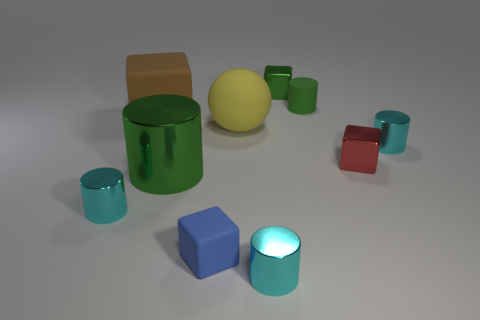Subtract all cyan spheres. How many cyan cylinders are left? 3 Subtract all green rubber cylinders. How many cylinders are left? 4 Subtract 1 cylinders. How many cylinders are left? 4 Subtract all purple cylinders. Subtract all purple cubes. How many cylinders are left? 5 Subtract all spheres. How many objects are left? 9 Subtract all objects. Subtract all large metal spheres. How many objects are left? 0 Add 7 big green metallic objects. How many big green metallic objects are left? 8 Add 2 brown shiny cylinders. How many brown shiny cylinders exist? 2 Subtract 0 brown cylinders. How many objects are left? 10 